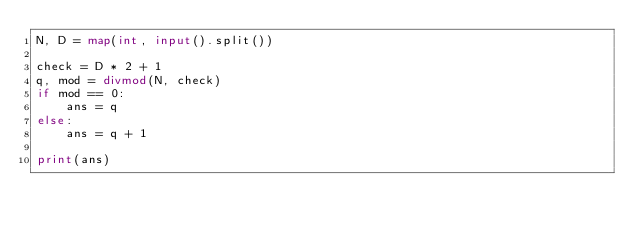<code> <loc_0><loc_0><loc_500><loc_500><_Python_>N, D = map(int, input().split())

check = D * 2 + 1
q, mod = divmod(N, check)
if mod == 0:
    ans = q
else:
    ans = q + 1

print(ans)
</code> 